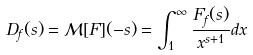Convert formula to latex. <formula><loc_0><loc_0><loc_500><loc_500>D _ { f } ( s ) = { \mathcal { M } } [ F ] ( - s ) = \int _ { 1 } ^ { \infty } { \frac { F _ { f } ( s ) } { x ^ { s + 1 } } } d x</formula> 